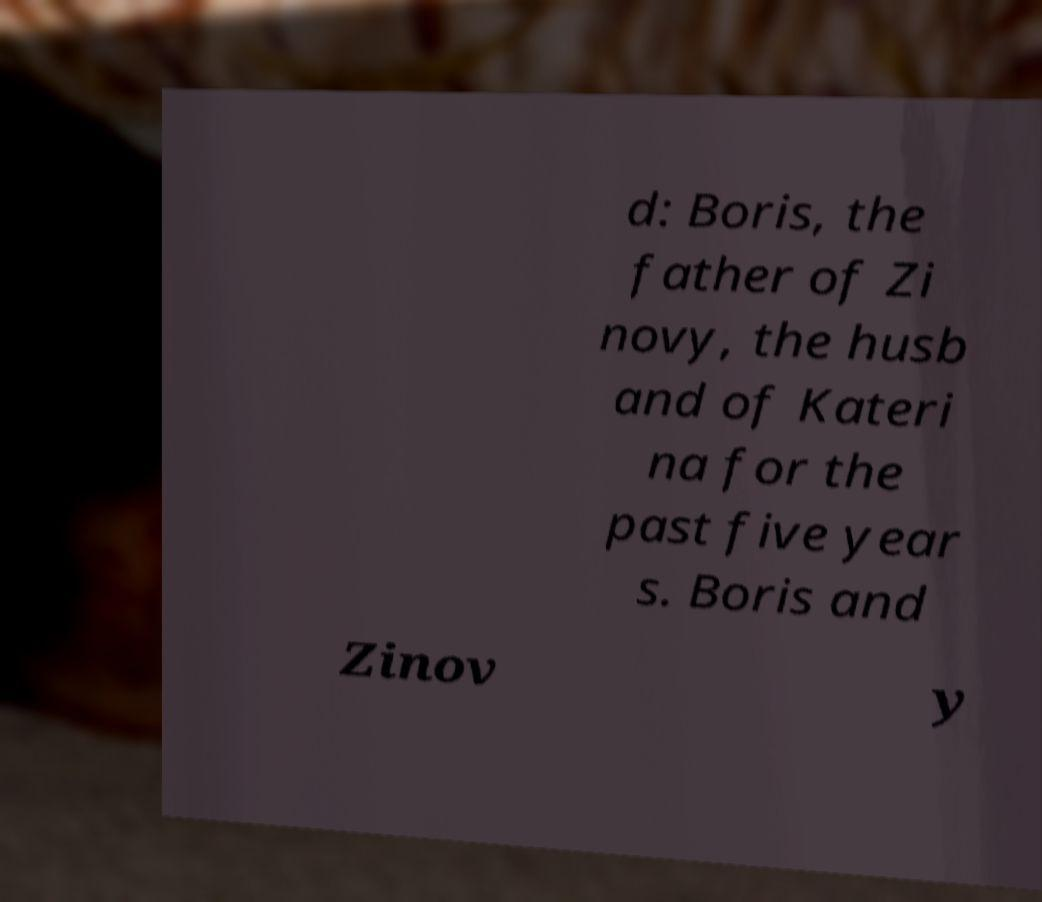Can you read and provide the text displayed in the image?This photo seems to have some interesting text. Can you extract and type it out for me? d: Boris, the father of Zi novy, the husb and of Kateri na for the past five year s. Boris and Zinov y 